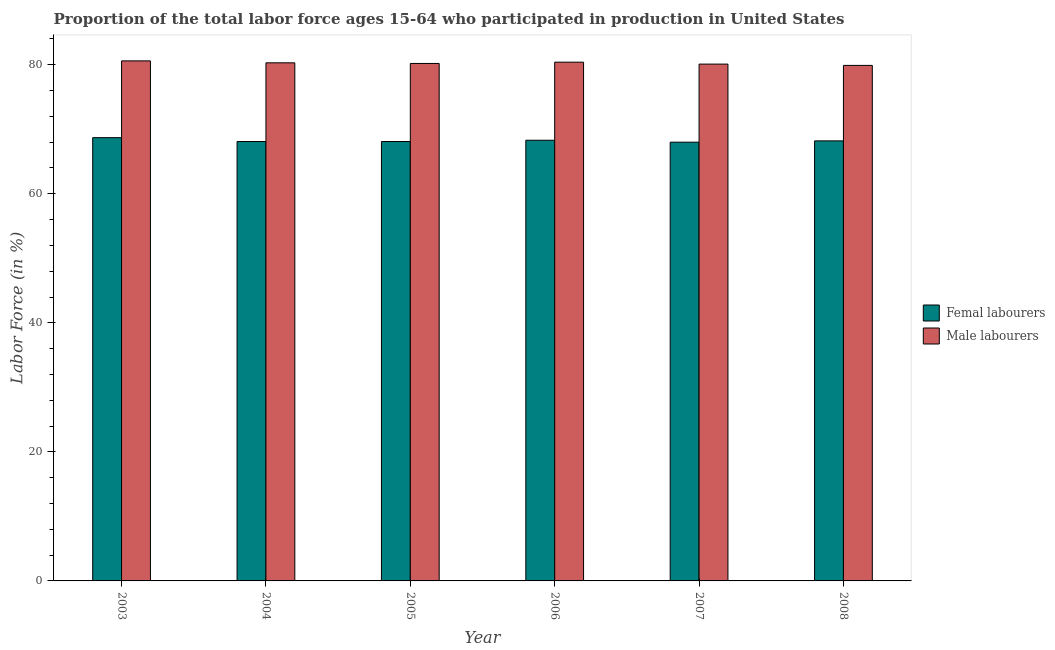How many bars are there on the 4th tick from the left?
Your answer should be compact. 2. How many bars are there on the 1st tick from the right?
Make the answer very short. 2. What is the label of the 6th group of bars from the left?
Ensure brevity in your answer.  2008. In how many cases, is the number of bars for a given year not equal to the number of legend labels?
Make the answer very short. 0. What is the percentage of male labour force in 2003?
Provide a succinct answer. 80.6. Across all years, what is the maximum percentage of female labor force?
Give a very brief answer. 68.7. In which year was the percentage of female labor force minimum?
Offer a terse response. 2007. What is the total percentage of male labour force in the graph?
Provide a succinct answer. 481.5. What is the difference between the percentage of female labor force in 2003 and that in 2006?
Provide a short and direct response. 0.4. What is the difference between the percentage of male labour force in 2004 and the percentage of female labor force in 2007?
Keep it short and to the point. 0.2. What is the average percentage of female labor force per year?
Provide a succinct answer. 68.23. In the year 2007, what is the difference between the percentage of female labor force and percentage of male labour force?
Offer a very short reply. 0. What is the ratio of the percentage of male labour force in 2004 to that in 2005?
Give a very brief answer. 1. What is the difference between the highest and the second highest percentage of female labor force?
Your answer should be compact. 0.4. What is the difference between the highest and the lowest percentage of female labor force?
Keep it short and to the point. 0.7. In how many years, is the percentage of female labor force greater than the average percentage of female labor force taken over all years?
Provide a succinct answer. 2. Is the sum of the percentage of male labour force in 2003 and 2006 greater than the maximum percentage of female labor force across all years?
Your answer should be very brief. Yes. What does the 2nd bar from the left in 2003 represents?
Your answer should be very brief. Male labourers. What does the 1st bar from the right in 2008 represents?
Offer a terse response. Male labourers. Are the values on the major ticks of Y-axis written in scientific E-notation?
Your answer should be very brief. No. Does the graph contain grids?
Keep it short and to the point. No. How many legend labels are there?
Ensure brevity in your answer.  2. How are the legend labels stacked?
Make the answer very short. Vertical. What is the title of the graph?
Your answer should be very brief. Proportion of the total labor force ages 15-64 who participated in production in United States. Does "Current education expenditure" appear as one of the legend labels in the graph?
Your answer should be compact. No. What is the label or title of the X-axis?
Your response must be concise. Year. What is the label or title of the Y-axis?
Provide a succinct answer. Labor Force (in %). What is the Labor Force (in %) in Femal labourers in 2003?
Make the answer very short. 68.7. What is the Labor Force (in %) in Male labourers in 2003?
Your response must be concise. 80.6. What is the Labor Force (in %) of Femal labourers in 2004?
Your response must be concise. 68.1. What is the Labor Force (in %) in Male labourers in 2004?
Make the answer very short. 80.3. What is the Labor Force (in %) of Femal labourers in 2005?
Offer a very short reply. 68.1. What is the Labor Force (in %) in Male labourers in 2005?
Provide a short and direct response. 80.2. What is the Labor Force (in %) of Femal labourers in 2006?
Give a very brief answer. 68.3. What is the Labor Force (in %) in Male labourers in 2006?
Your response must be concise. 80.4. What is the Labor Force (in %) in Femal labourers in 2007?
Ensure brevity in your answer.  68. What is the Labor Force (in %) in Male labourers in 2007?
Your answer should be compact. 80.1. What is the Labor Force (in %) of Femal labourers in 2008?
Offer a very short reply. 68.2. What is the Labor Force (in %) of Male labourers in 2008?
Provide a short and direct response. 79.9. Across all years, what is the maximum Labor Force (in %) of Femal labourers?
Ensure brevity in your answer.  68.7. Across all years, what is the maximum Labor Force (in %) in Male labourers?
Give a very brief answer. 80.6. Across all years, what is the minimum Labor Force (in %) of Male labourers?
Provide a succinct answer. 79.9. What is the total Labor Force (in %) of Femal labourers in the graph?
Your answer should be compact. 409.4. What is the total Labor Force (in %) in Male labourers in the graph?
Keep it short and to the point. 481.5. What is the difference between the Labor Force (in %) in Male labourers in 2003 and that in 2004?
Your answer should be compact. 0.3. What is the difference between the Labor Force (in %) in Femal labourers in 2003 and that in 2005?
Your answer should be compact. 0.6. What is the difference between the Labor Force (in %) in Male labourers in 2003 and that in 2005?
Ensure brevity in your answer.  0.4. What is the difference between the Labor Force (in %) of Male labourers in 2003 and that in 2006?
Your answer should be very brief. 0.2. What is the difference between the Labor Force (in %) in Male labourers in 2003 and that in 2007?
Your answer should be compact. 0.5. What is the difference between the Labor Force (in %) of Male labourers in 2003 and that in 2008?
Offer a very short reply. 0.7. What is the difference between the Labor Force (in %) of Femal labourers in 2004 and that in 2006?
Ensure brevity in your answer.  -0.2. What is the difference between the Labor Force (in %) of Male labourers in 2005 and that in 2007?
Ensure brevity in your answer.  0.1. What is the difference between the Labor Force (in %) of Femal labourers in 2005 and that in 2008?
Offer a very short reply. -0.1. What is the difference between the Labor Force (in %) of Femal labourers in 2006 and that in 2007?
Your answer should be compact. 0.3. What is the difference between the Labor Force (in %) of Male labourers in 2006 and that in 2007?
Offer a very short reply. 0.3. What is the difference between the Labor Force (in %) in Femal labourers in 2006 and that in 2008?
Ensure brevity in your answer.  0.1. What is the difference between the Labor Force (in %) of Male labourers in 2006 and that in 2008?
Your answer should be compact. 0.5. What is the difference between the Labor Force (in %) of Male labourers in 2007 and that in 2008?
Ensure brevity in your answer.  0.2. What is the difference between the Labor Force (in %) of Femal labourers in 2003 and the Labor Force (in %) of Male labourers in 2004?
Your response must be concise. -11.6. What is the difference between the Labor Force (in %) of Femal labourers in 2004 and the Labor Force (in %) of Male labourers in 2005?
Your response must be concise. -12.1. What is the difference between the Labor Force (in %) of Femal labourers in 2004 and the Labor Force (in %) of Male labourers in 2007?
Provide a succinct answer. -12. What is the difference between the Labor Force (in %) in Femal labourers in 2004 and the Labor Force (in %) in Male labourers in 2008?
Your response must be concise. -11.8. What is the difference between the Labor Force (in %) of Femal labourers in 2005 and the Labor Force (in %) of Male labourers in 2007?
Your answer should be very brief. -12. What is the difference between the Labor Force (in %) of Femal labourers in 2006 and the Labor Force (in %) of Male labourers in 2008?
Your answer should be compact. -11.6. What is the difference between the Labor Force (in %) of Femal labourers in 2007 and the Labor Force (in %) of Male labourers in 2008?
Provide a short and direct response. -11.9. What is the average Labor Force (in %) of Femal labourers per year?
Provide a short and direct response. 68.23. What is the average Labor Force (in %) of Male labourers per year?
Give a very brief answer. 80.25. In the year 2004, what is the difference between the Labor Force (in %) of Femal labourers and Labor Force (in %) of Male labourers?
Ensure brevity in your answer.  -12.2. In the year 2006, what is the difference between the Labor Force (in %) of Femal labourers and Labor Force (in %) of Male labourers?
Give a very brief answer. -12.1. In the year 2007, what is the difference between the Labor Force (in %) of Femal labourers and Labor Force (in %) of Male labourers?
Provide a succinct answer. -12.1. In the year 2008, what is the difference between the Labor Force (in %) of Femal labourers and Labor Force (in %) of Male labourers?
Your response must be concise. -11.7. What is the ratio of the Labor Force (in %) of Femal labourers in 2003 to that in 2004?
Provide a succinct answer. 1.01. What is the ratio of the Labor Force (in %) in Male labourers in 2003 to that in 2004?
Your response must be concise. 1. What is the ratio of the Labor Force (in %) in Femal labourers in 2003 to that in 2005?
Your answer should be compact. 1.01. What is the ratio of the Labor Force (in %) in Femal labourers in 2003 to that in 2006?
Offer a very short reply. 1.01. What is the ratio of the Labor Force (in %) in Femal labourers in 2003 to that in 2007?
Make the answer very short. 1.01. What is the ratio of the Labor Force (in %) of Femal labourers in 2003 to that in 2008?
Ensure brevity in your answer.  1.01. What is the ratio of the Labor Force (in %) in Male labourers in 2003 to that in 2008?
Make the answer very short. 1.01. What is the ratio of the Labor Force (in %) in Male labourers in 2004 to that in 2005?
Make the answer very short. 1. What is the ratio of the Labor Force (in %) in Male labourers in 2004 to that in 2006?
Your answer should be compact. 1. What is the ratio of the Labor Force (in %) in Femal labourers in 2004 to that in 2007?
Offer a terse response. 1. What is the ratio of the Labor Force (in %) of Male labourers in 2004 to that in 2007?
Your response must be concise. 1. What is the ratio of the Labor Force (in %) of Femal labourers in 2004 to that in 2008?
Ensure brevity in your answer.  1. What is the ratio of the Labor Force (in %) of Femal labourers in 2005 to that in 2006?
Provide a succinct answer. 1. What is the ratio of the Labor Force (in %) in Male labourers in 2005 to that in 2006?
Offer a very short reply. 1. What is the ratio of the Labor Force (in %) in Femal labourers in 2005 to that in 2008?
Make the answer very short. 1. What is the ratio of the Labor Force (in %) of Male labourers in 2005 to that in 2008?
Your response must be concise. 1. What is the ratio of the Labor Force (in %) in Male labourers in 2006 to that in 2007?
Offer a terse response. 1. What is the ratio of the Labor Force (in %) of Femal labourers in 2007 to that in 2008?
Make the answer very short. 1. What is the ratio of the Labor Force (in %) in Male labourers in 2007 to that in 2008?
Offer a very short reply. 1. What is the difference between the highest and the second highest Labor Force (in %) of Femal labourers?
Make the answer very short. 0.4. What is the difference between the highest and the second highest Labor Force (in %) of Male labourers?
Give a very brief answer. 0.2. What is the difference between the highest and the lowest Labor Force (in %) in Male labourers?
Keep it short and to the point. 0.7. 